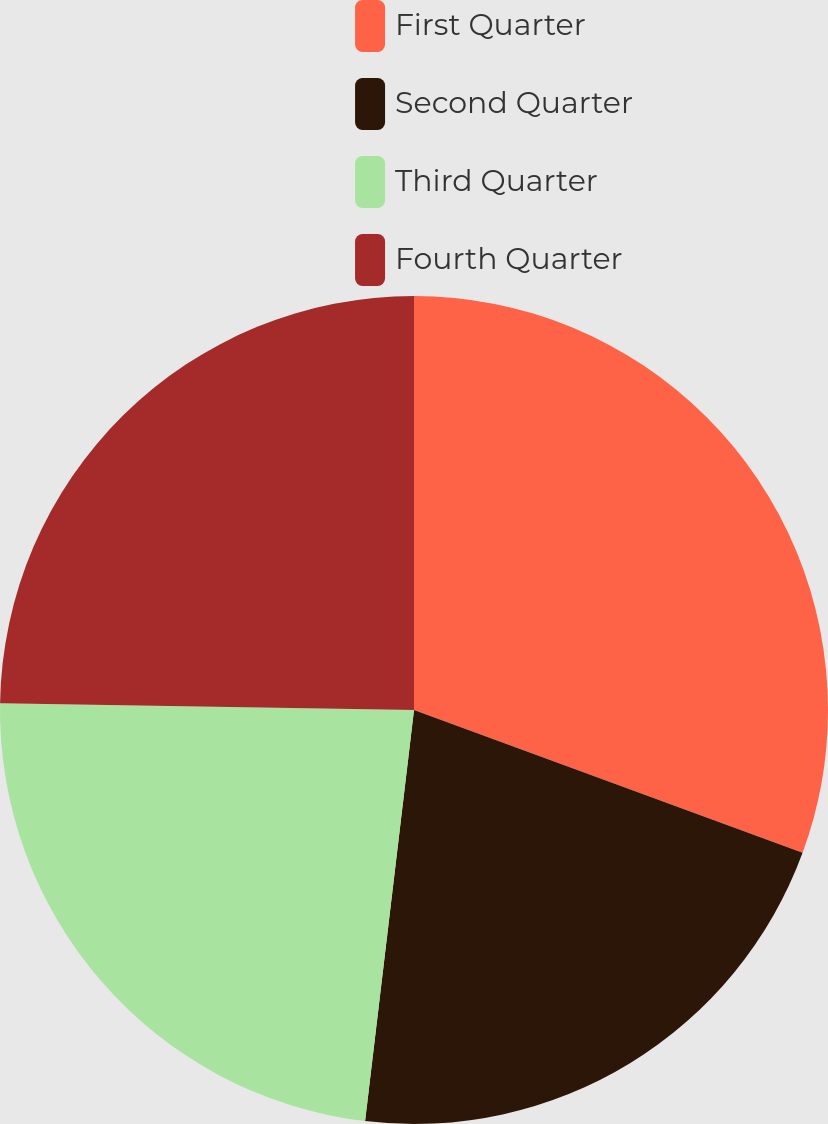Convert chart to OTSL. <chart><loc_0><loc_0><loc_500><loc_500><pie_chart><fcel>First Quarter<fcel>Second Quarter<fcel>Third Quarter<fcel>Fourth Quarter<nl><fcel>30.61%<fcel>21.28%<fcel>23.38%<fcel>24.74%<nl></chart> 